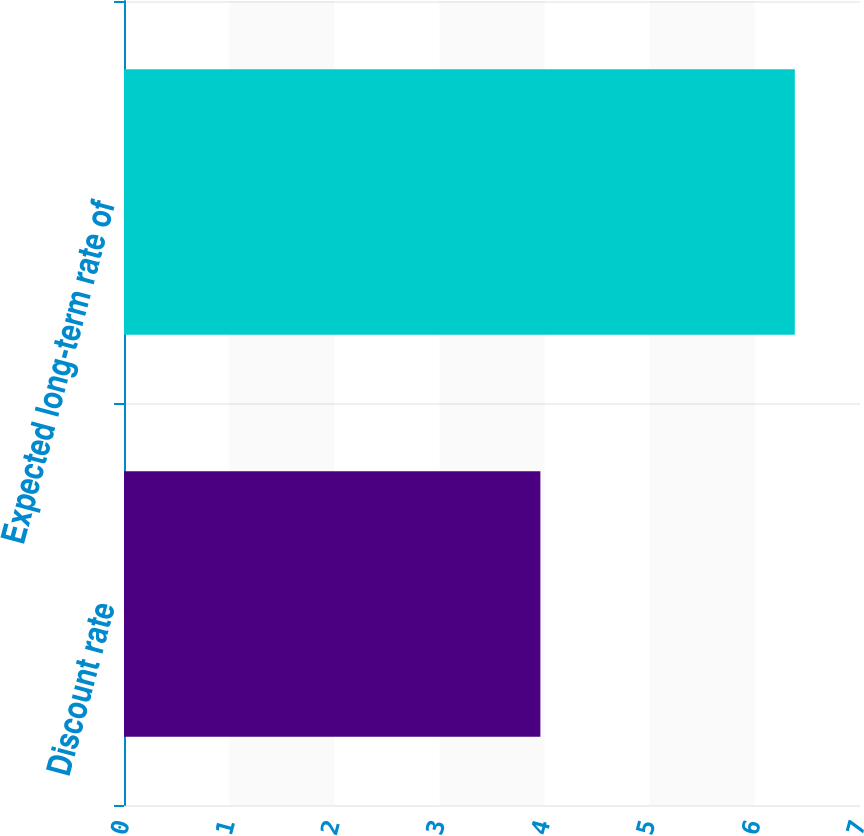<chart> <loc_0><loc_0><loc_500><loc_500><bar_chart><fcel>Discount rate<fcel>Expected long-term rate of<nl><fcel>3.96<fcel>6.38<nl></chart> 